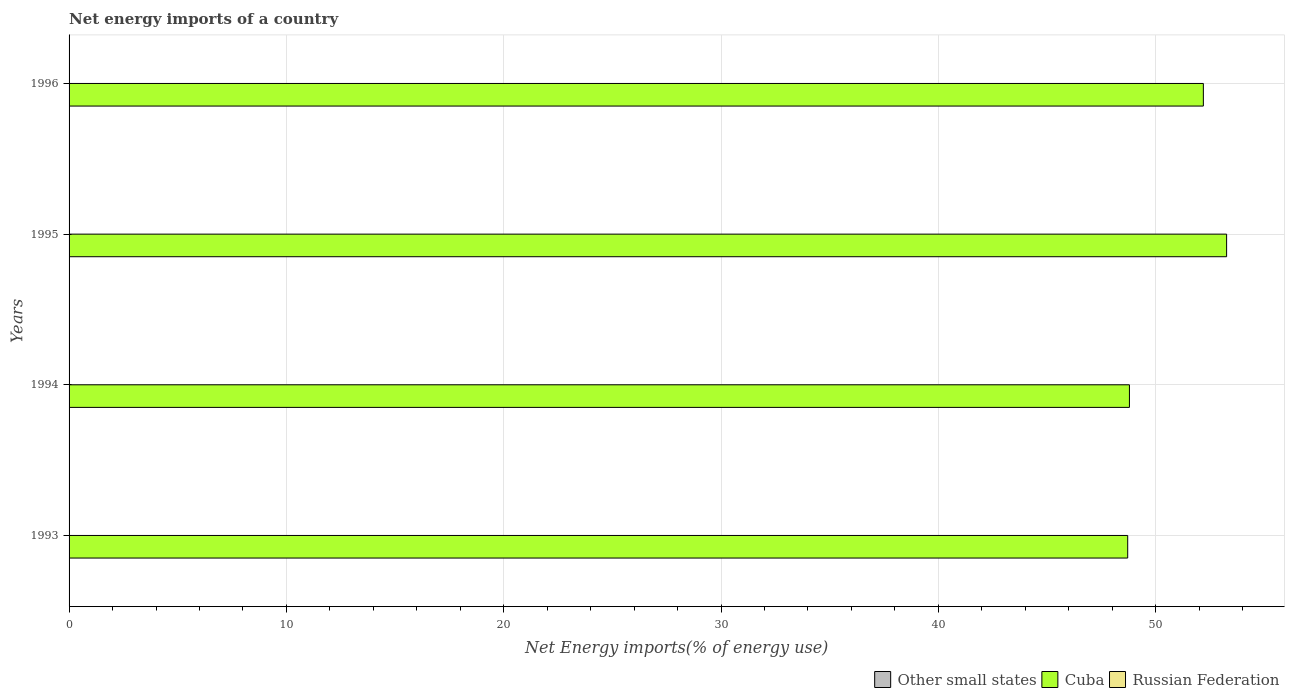Are the number of bars per tick equal to the number of legend labels?
Keep it short and to the point. No. Are the number of bars on each tick of the Y-axis equal?
Ensure brevity in your answer.  Yes. How many bars are there on the 1st tick from the bottom?
Keep it short and to the point. 1. In how many cases, is the number of bars for a given year not equal to the number of legend labels?
Make the answer very short. 4. What is the net energy imports in Cuba in 1996?
Your answer should be compact. 52.19. Across all years, what is the maximum net energy imports in Cuba?
Make the answer very short. 53.26. Across all years, what is the minimum net energy imports in Other small states?
Your response must be concise. 0. What is the total net energy imports in Cuba in the graph?
Provide a succinct answer. 202.96. What is the difference between the net energy imports in Cuba in 1993 and that in 1994?
Give a very brief answer. -0.08. What is the difference between the net energy imports in Other small states in 1994 and the net energy imports in Cuba in 1995?
Ensure brevity in your answer.  -53.26. What is the average net energy imports in Other small states per year?
Your answer should be very brief. 0. In how many years, is the net energy imports in Russian Federation greater than 52 %?
Your answer should be compact. 0. What is the ratio of the net energy imports in Cuba in 1994 to that in 1995?
Offer a very short reply. 0.92. What is the difference between the highest and the second highest net energy imports in Cuba?
Your answer should be very brief. 1.07. What is the difference between the highest and the lowest net energy imports in Cuba?
Your answer should be compact. 4.55. Does the graph contain any zero values?
Keep it short and to the point. Yes. How many legend labels are there?
Your answer should be very brief. 3. How are the legend labels stacked?
Provide a succinct answer. Horizontal. What is the title of the graph?
Keep it short and to the point. Net energy imports of a country. What is the label or title of the X-axis?
Your answer should be compact. Net Energy imports(% of energy use). What is the label or title of the Y-axis?
Your answer should be very brief. Years. What is the Net Energy imports(% of energy use) in Cuba in 1993?
Offer a very short reply. 48.71. What is the Net Energy imports(% of energy use) in Other small states in 1994?
Your response must be concise. 0. What is the Net Energy imports(% of energy use) of Cuba in 1994?
Ensure brevity in your answer.  48.79. What is the Net Energy imports(% of energy use) in Russian Federation in 1994?
Provide a short and direct response. 0. What is the Net Energy imports(% of energy use) of Other small states in 1995?
Keep it short and to the point. 0. What is the Net Energy imports(% of energy use) of Cuba in 1995?
Offer a terse response. 53.26. What is the Net Energy imports(% of energy use) in Cuba in 1996?
Keep it short and to the point. 52.19. What is the Net Energy imports(% of energy use) in Russian Federation in 1996?
Provide a succinct answer. 0. Across all years, what is the maximum Net Energy imports(% of energy use) of Cuba?
Make the answer very short. 53.26. Across all years, what is the minimum Net Energy imports(% of energy use) of Cuba?
Your answer should be very brief. 48.71. What is the total Net Energy imports(% of energy use) in Cuba in the graph?
Your response must be concise. 202.96. What is the difference between the Net Energy imports(% of energy use) in Cuba in 1993 and that in 1994?
Offer a very short reply. -0.08. What is the difference between the Net Energy imports(% of energy use) of Cuba in 1993 and that in 1995?
Provide a succinct answer. -4.55. What is the difference between the Net Energy imports(% of energy use) in Cuba in 1993 and that in 1996?
Offer a terse response. -3.48. What is the difference between the Net Energy imports(% of energy use) in Cuba in 1994 and that in 1995?
Provide a succinct answer. -4.47. What is the difference between the Net Energy imports(% of energy use) in Cuba in 1994 and that in 1996?
Ensure brevity in your answer.  -3.4. What is the difference between the Net Energy imports(% of energy use) of Cuba in 1995 and that in 1996?
Your response must be concise. 1.07. What is the average Net Energy imports(% of energy use) of Other small states per year?
Ensure brevity in your answer.  0. What is the average Net Energy imports(% of energy use) in Cuba per year?
Provide a short and direct response. 50.74. What is the ratio of the Net Energy imports(% of energy use) of Cuba in 1993 to that in 1995?
Offer a terse response. 0.91. What is the ratio of the Net Energy imports(% of energy use) of Cuba in 1994 to that in 1995?
Keep it short and to the point. 0.92. What is the ratio of the Net Energy imports(% of energy use) in Cuba in 1994 to that in 1996?
Offer a very short reply. 0.93. What is the ratio of the Net Energy imports(% of energy use) of Cuba in 1995 to that in 1996?
Provide a succinct answer. 1.02. What is the difference between the highest and the second highest Net Energy imports(% of energy use) of Cuba?
Keep it short and to the point. 1.07. What is the difference between the highest and the lowest Net Energy imports(% of energy use) in Cuba?
Offer a very short reply. 4.55. 